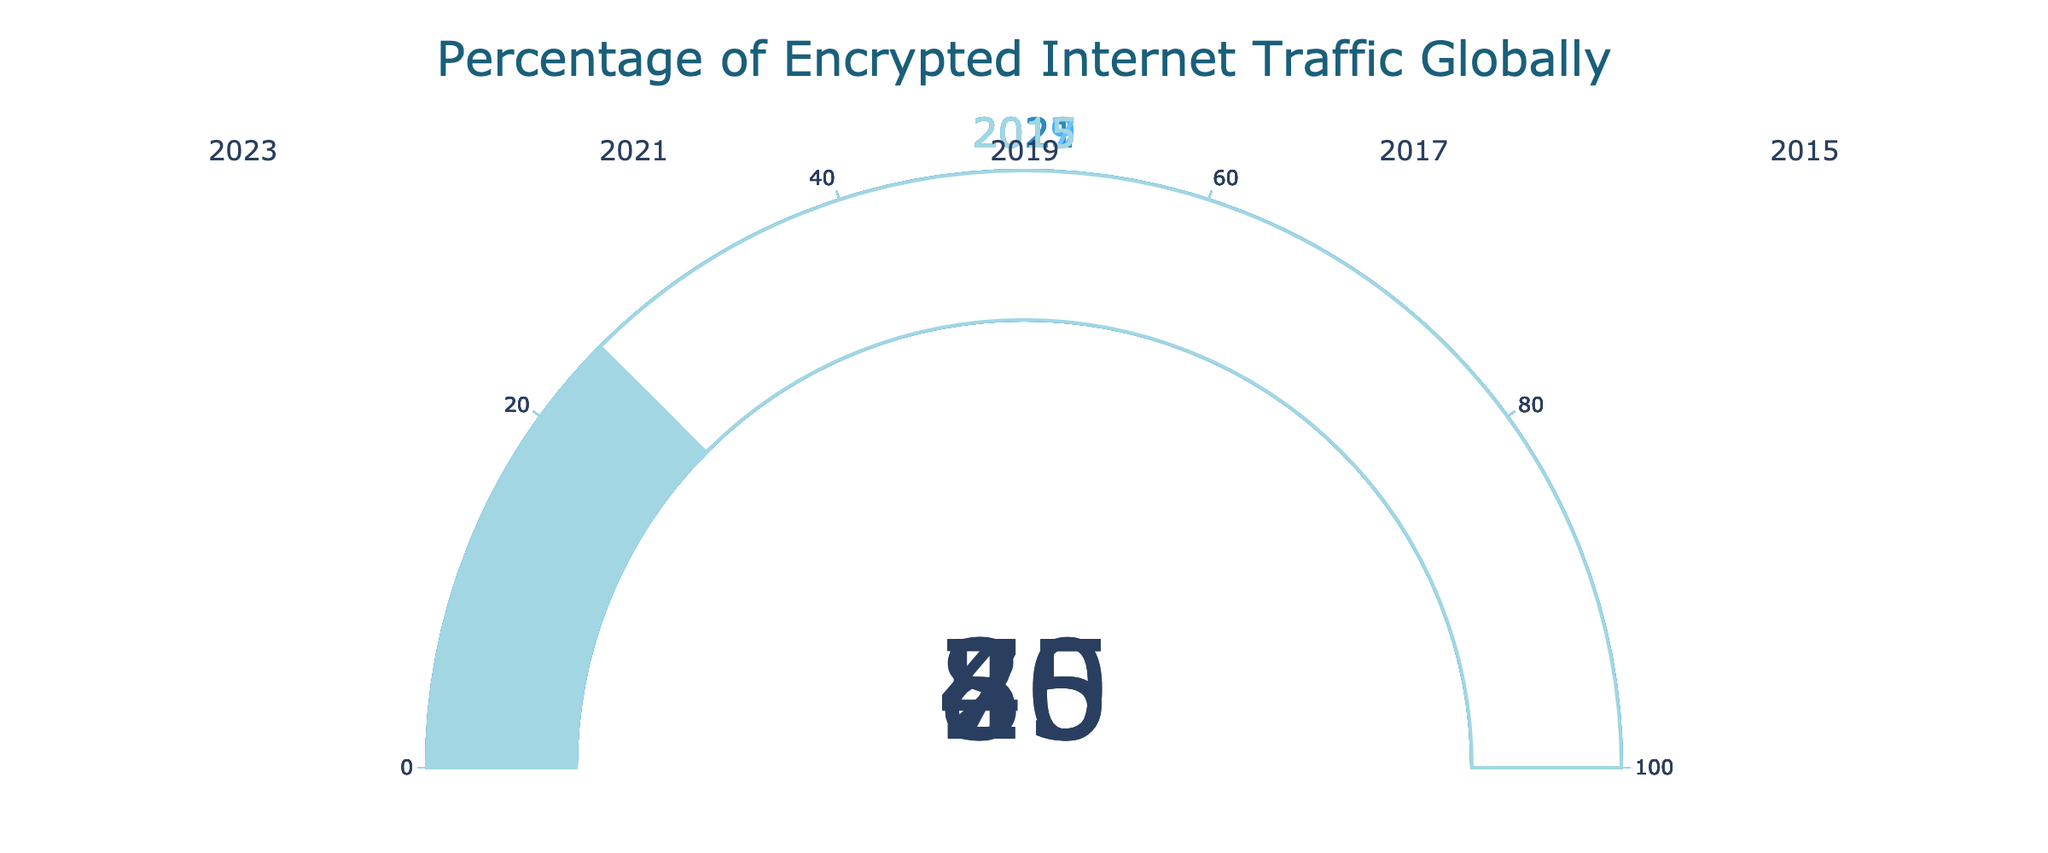what does the figure represent? The figure represents the percentage of encrypted internet traffic globally.
Answer: Percentage of encrypted internet traffic globally How many data points are presented in the figure? There are five data points corresponding to different years.
Answer: 5 What is the title of the figure? The title of the figure is "Percentage of Encrypted Internet Traffic Globally".
Answer: Percentage of Encrypted Internet Traffic Globally Which year has the highest percentage of encrypted internet traffic? By looking at all the gauges, the year 2023 shows the highest value at 85%.
Answer: 2023 Which year has the smallest percentage of encrypted internet traffic? By looking at all the gauges, the year 2015 shows the smallest value at 25%.
Answer: 2015 What’s the percentage increase in encrypted internet traffic from 2015 to 2023? The percentage increase can be calculated by subtracting the 2015 value (25%) from the 2023 value (85%). The result is 85% - 25% = 60%.
Answer: 60% How does the percentage of encrypted traffic in 2021 compare to that in 2019? The percentage in 2021 (70%) is higher than in 2019 (55%).
Answer: 2021 has 15% more than 2019 What’s the average percentage of encrypted internet traffic over the years presented? Sum the percentages (25 + 40 + 55 + 70 + 85) = 275, then divide by the number of data points (5). The average is 275 / 5 = 55%.
Answer: 55% How many years show a percentage above 50%? The years 2019, 2021, and 2023 have percentages above 50%, which is 3 years.
Answer: 3 years What’s the median percentage of encrypted internet traffic over the years presented? Ordering the presented data percentages (25, 40, 55, 70, 85), the middle value is 55%.
Answer: 55% 